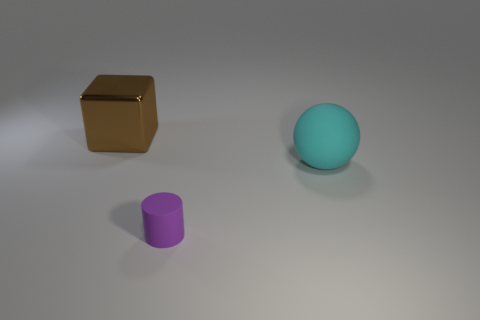There is a large object that is in front of the big brown block; how many big matte things are behind it?
Give a very brief answer. 0. How many other objects are the same size as the rubber ball?
Your answer should be very brief. 1. Is the color of the tiny object the same as the large matte sphere?
Ensure brevity in your answer.  No. Does the big object that is right of the brown cube have the same shape as the big shiny thing?
Make the answer very short. No. What number of things are to the left of the cyan rubber ball and in front of the shiny object?
Give a very brief answer. 1. What is the material of the big cyan ball?
Make the answer very short. Rubber. Is there any other thing that is the same color as the cylinder?
Your response must be concise. No. Is the material of the large cyan thing the same as the small thing?
Your response must be concise. Yes. There is a rubber object on the left side of the large thing that is on the right side of the metallic thing; how many purple matte things are left of it?
Provide a short and direct response. 0. How many large things are there?
Your response must be concise. 2. 